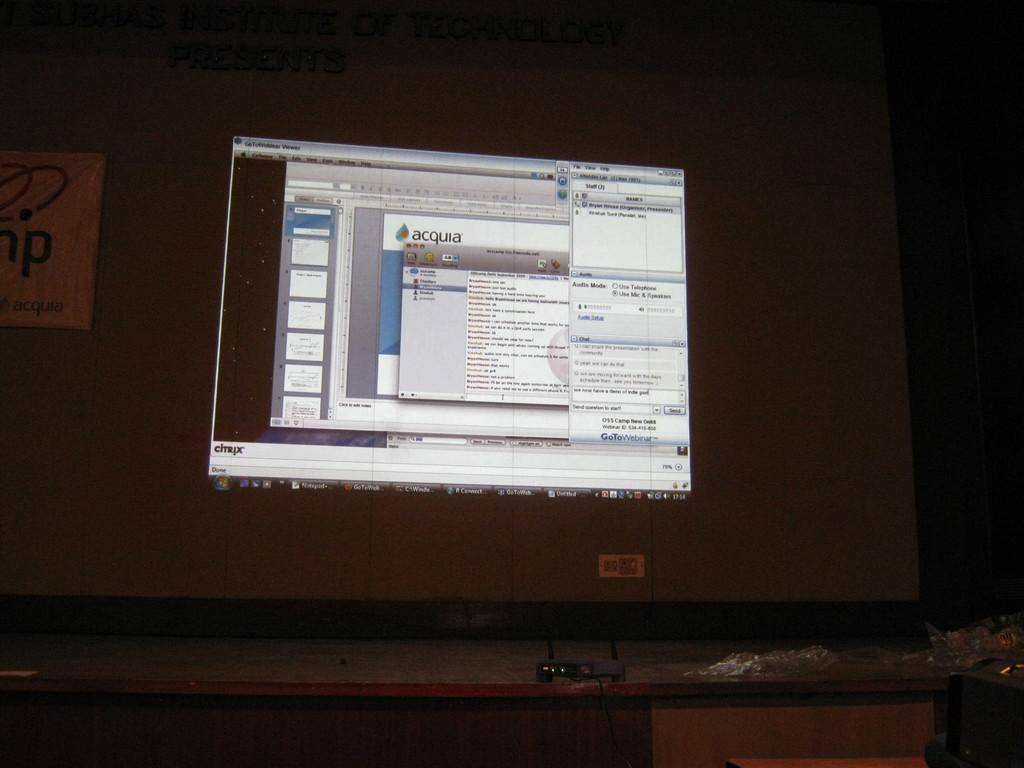<image>
Render a clear and concise summary of the photo. Computer monitor which shows the word Acquia on the screen. 